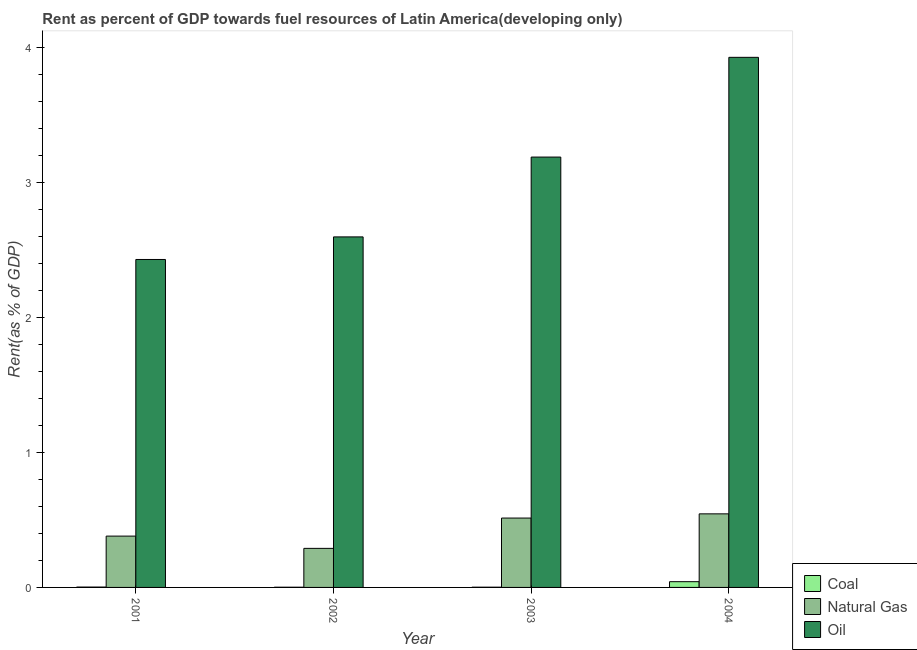How many different coloured bars are there?
Your answer should be very brief. 3. How many groups of bars are there?
Ensure brevity in your answer.  4. Are the number of bars per tick equal to the number of legend labels?
Offer a very short reply. Yes. What is the label of the 1st group of bars from the left?
Make the answer very short. 2001. In how many cases, is the number of bars for a given year not equal to the number of legend labels?
Your response must be concise. 0. What is the rent towards coal in 2004?
Give a very brief answer. 0.04. Across all years, what is the maximum rent towards coal?
Keep it short and to the point. 0.04. Across all years, what is the minimum rent towards coal?
Ensure brevity in your answer.  0. In which year was the rent towards coal minimum?
Provide a succinct answer. 2002. What is the total rent towards oil in the graph?
Offer a very short reply. 12.15. What is the difference between the rent towards natural gas in 2001 and that in 2002?
Your response must be concise. 0.09. What is the difference between the rent towards oil in 2003 and the rent towards coal in 2004?
Your answer should be compact. -0.74. What is the average rent towards coal per year?
Your response must be concise. 0.01. In the year 2003, what is the difference between the rent towards natural gas and rent towards coal?
Offer a terse response. 0. What is the ratio of the rent towards oil in 2001 to that in 2004?
Your response must be concise. 0.62. Is the rent towards natural gas in 2001 less than that in 2003?
Your response must be concise. Yes. What is the difference between the highest and the second highest rent towards natural gas?
Offer a very short reply. 0.03. What is the difference between the highest and the lowest rent towards natural gas?
Offer a very short reply. 0.26. In how many years, is the rent towards natural gas greater than the average rent towards natural gas taken over all years?
Your answer should be very brief. 2. What does the 1st bar from the left in 2003 represents?
Give a very brief answer. Coal. What does the 2nd bar from the right in 2002 represents?
Keep it short and to the point. Natural Gas. Is it the case that in every year, the sum of the rent towards coal and rent towards natural gas is greater than the rent towards oil?
Your answer should be very brief. No. How many years are there in the graph?
Your answer should be compact. 4. What is the difference between two consecutive major ticks on the Y-axis?
Keep it short and to the point. 1. How many legend labels are there?
Make the answer very short. 3. How are the legend labels stacked?
Make the answer very short. Vertical. What is the title of the graph?
Your answer should be very brief. Rent as percent of GDP towards fuel resources of Latin America(developing only). What is the label or title of the Y-axis?
Give a very brief answer. Rent(as % of GDP). What is the Rent(as % of GDP) in Coal in 2001?
Your response must be concise. 0. What is the Rent(as % of GDP) of Natural Gas in 2001?
Keep it short and to the point. 0.38. What is the Rent(as % of GDP) of Oil in 2001?
Provide a short and direct response. 2.43. What is the Rent(as % of GDP) in Coal in 2002?
Make the answer very short. 0. What is the Rent(as % of GDP) of Natural Gas in 2002?
Your answer should be compact. 0.29. What is the Rent(as % of GDP) of Oil in 2002?
Provide a succinct answer. 2.6. What is the Rent(as % of GDP) in Coal in 2003?
Ensure brevity in your answer.  0. What is the Rent(as % of GDP) in Natural Gas in 2003?
Make the answer very short. 0.51. What is the Rent(as % of GDP) of Oil in 2003?
Offer a very short reply. 3.19. What is the Rent(as % of GDP) in Coal in 2004?
Offer a terse response. 0.04. What is the Rent(as % of GDP) in Natural Gas in 2004?
Provide a short and direct response. 0.55. What is the Rent(as % of GDP) of Oil in 2004?
Your response must be concise. 3.93. Across all years, what is the maximum Rent(as % of GDP) of Coal?
Your answer should be very brief. 0.04. Across all years, what is the maximum Rent(as % of GDP) in Natural Gas?
Ensure brevity in your answer.  0.55. Across all years, what is the maximum Rent(as % of GDP) in Oil?
Give a very brief answer. 3.93. Across all years, what is the minimum Rent(as % of GDP) of Coal?
Keep it short and to the point. 0. Across all years, what is the minimum Rent(as % of GDP) in Natural Gas?
Make the answer very short. 0.29. Across all years, what is the minimum Rent(as % of GDP) of Oil?
Ensure brevity in your answer.  2.43. What is the total Rent(as % of GDP) of Coal in the graph?
Make the answer very short. 0.05. What is the total Rent(as % of GDP) in Natural Gas in the graph?
Offer a terse response. 1.73. What is the total Rent(as % of GDP) in Oil in the graph?
Provide a short and direct response. 12.15. What is the difference between the Rent(as % of GDP) in Coal in 2001 and that in 2002?
Offer a very short reply. 0. What is the difference between the Rent(as % of GDP) of Natural Gas in 2001 and that in 2002?
Provide a short and direct response. 0.09. What is the difference between the Rent(as % of GDP) in Oil in 2001 and that in 2002?
Offer a terse response. -0.17. What is the difference between the Rent(as % of GDP) in Coal in 2001 and that in 2003?
Offer a very short reply. 0. What is the difference between the Rent(as % of GDP) of Natural Gas in 2001 and that in 2003?
Your response must be concise. -0.13. What is the difference between the Rent(as % of GDP) of Oil in 2001 and that in 2003?
Provide a succinct answer. -0.76. What is the difference between the Rent(as % of GDP) in Coal in 2001 and that in 2004?
Give a very brief answer. -0.04. What is the difference between the Rent(as % of GDP) of Natural Gas in 2001 and that in 2004?
Your response must be concise. -0.16. What is the difference between the Rent(as % of GDP) of Oil in 2001 and that in 2004?
Your answer should be very brief. -1.5. What is the difference between the Rent(as % of GDP) in Coal in 2002 and that in 2003?
Your answer should be compact. -0. What is the difference between the Rent(as % of GDP) in Natural Gas in 2002 and that in 2003?
Offer a very short reply. -0.22. What is the difference between the Rent(as % of GDP) in Oil in 2002 and that in 2003?
Give a very brief answer. -0.59. What is the difference between the Rent(as % of GDP) of Coal in 2002 and that in 2004?
Provide a short and direct response. -0.04. What is the difference between the Rent(as % of GDP) of Natural Gas in 2002 and that in 2004?
Ensure brevity in your answer.  -0.26. What is the difference between the Rent(as % of GDP) in Oil in 2002 and that in 2004?
Give a very brief answer. -1.33. What is the difference between the Rent(as % of GDP) of Coal in 2003 and that in 2004?
Offer a very short reply. -0.04. What is the difference between the Rent(as % of GDP) in Natural Gas in 2003 and that in 2004?
Your answer should be compact. -0.03. What is the difference between the Rent(as % of GDP) of Oil in 2003 and that in 2004?
Your answer should be very brief. -0.74. What is the difference between the Rent(as % of GDP) of Coal in 2001 and the Rent(as % of GDP) of Natural Gas in 2002?
Provide a short and direct response. -0.29. What is the difference between the Rent(as % of GDP) of Coal in 2001 and the Rent(as % of GDP) of Oil in 2002?
Make the answer very short. -2.6. What is the difference between the Rent(as % of GDP) in Natural Gas in 2001 and the Rent(as % of GDP) in Oil in 2002?
Provide a succinct answer. -2.22. What is the difference between the Rent(as % of GDP) of Coal in 2001 and the Rent(as % of GDP) of Natural Gas in 2003?
Your answer should be very brief. -0.51. What is the difference between the Rent(as % of GDP) in Coal in 2001 and the Rent(as % of GDP) in Oil in 2003?
Offer a terse response. -3.19. What is the difference between the Rent(as % of GDP) of Natural Gas in 2001 and the Rent(as % of GDP) of Oil in 2003?
Your answer should be very brief. -2.81. What is the difference between the Rent(as % of GDP) in Coal in 2001 and the Rent(as % of GDP) in Natural Gas in 2004?
Offer a very short reply. -0.54. What is the difference between the Rent(as % of GDP) of Coal in 2001 and the Rent(as % of GDP) of Oil in 2004?
Give a very brief answer. -3.93. What is the difference between the Rent(as % of GDP) of Natural Gas in 2001 and the Rent(as % of GDP) of Oil in 2004?
Your answer should be compact. -3.55. What is the difference between the Rent(as % of GDP) in Coal in 2002 and the Rent(as % of GDP) in Natural Gas in 2003?
Give a very brief answer. -0.51. What is the difference between the Rent(as % of GDP) of Coal in 2002 and the Rent(as % of GDP) of Oil in 2003?
Keep it short and to the point. -3.19. What is the difference between the Rent(as % of GDP) in Natural Gas in 2002 and the Rent(as % of GDP) in Oil in 2003?
Provide a succinct answer. -2.9. What is the difference between the Rent(as % of GDP) of Coal in 2002 and the Rent(as % of GDP) of Natural Gas in 2004?
Provide a succinct answer. -0.54. What is the difference between the Rent(as % of GDP) in Coal in 2002 and the Rent(as % of GDP) in Oil in 2004?
Your answer should be very brief. -3.93. What is the difference between the Rent(as % of GDP) of Natural Gas in 2002 and the Rent(as % of GDP) of Oil in 2004?
Give a very brief answer. -3.64. What is the difference between the Rent(as % of GDP) of Coal in 2003 and the Rent(as % of GDP) of Natural Gas in 2004?
Make the answer very short. -0.54. What is the difference between the Rent(as % of GDP) in Coal in 2003 and the Rent(as % of GDP) in Oil in 2004?
Offer a terse response. -3.93. What is the difference between the Rent(as % of GDP) in Natural Gas in 2003 and the Rent(as % of GDP) in Oil in 2004?
Make the answer very short. -3.41. What is the average Rent(as % of GDP) in Coal per year?
Your response must be concise. 0.01. What is the average Rent(as % of GDP) of Natural Gas per year?
Make the answer very short. 0.43. What is the average Rent(as % of GDP) in Oil per year?
Offer a very short reply. 3.04. In the year 2001, what is the difference between the Rent(as % of GDP) in Coal and Rent(as % of GDP) in Natural Gas?
Provide a short and direct response. -0.38. In the year 2001, what is the difference between the Rent(as % of GDP) in Coal and Rent(as % of GDP) in Oil?
Your answer should be very brief. -2.43. In the year 2001, what is the difference between the Rent(as % of GDP) of Natural Gas and Rent(as % of GDP) of Oil?
Your answer should be compact. -2.05. In the year 2002, what is the difference between the Rent(as % of GDP) in Coal and Rent(as % of GDP) in Natural Gas?
Make the answer very short. -0.29. In the year 2002, what is the difference between the Rent(as % of GDP) in Coal and Rent(as % of GDP) in Oil?
Make the answer very short. -2.6. In the year 2002, what is the difference between the Rent(as % of GDP) of Natural Gas and Rent(as % of GDP) of Oil?
Your answer should be compact. -2.31. In the year 2003, what is the difference between the Rent(as % of GDP) in Coal and Rent(as % of GDP) in Natural Gas?
Make the answer very short. -0.51. In the year 2003, what is the difference between the Rent(as % of GDP) of Coal and Rent(as % of GDP) of Oil?
Your answer should be very brief. -3.19. In the year 2003, what is the difference between the Rent(as % of GDP) in Natural Gas and Rent(as % of GDP) in Oil?
Offer a terse response. -2.68. In the year 2004, what is the difference between the Rent(as % of GDP) in Coal and Rent(as % of GDP) in Natural Gas?
Provide a short and direct response. -0.5. In the year 2004, what is the difference between the Rent(as % of GDP) of Coal and Rent(as % of GDP) of Oil?
Your response must be concise. -3.89. In the year 2004, what is the difference between the Rent(as % of GDP) of Natural Gas and Rent(as % of GDP) of Oil?
Your answer should be compact. -3.38. What is the ratio of the Rent(as % of GDP) in Coal in 2001 to that in 2002?
Make the answer very short. 1.8. What is the ratio of the Rent(as % of GDP) of Natural Gas in 2001 to that in 2002?
Your answer should be compact. 1.31. What is the ratio of the Rent(as % of GDP) of Oil in 2001 to that in 2002?
Make the answer very short. 0.94. What is the ratio of the Rent(as % of GDP) of Coal in 2001 to that in 2003?
Offer a terse response. 1.48. What is the ratio of the Rent(as % of GDP) in Natural Gas in 2001 to that in 2003?
Your answer should be very brief. 0.74. What is the ratio of the Rent(as % of GDP) in Oil in 2001 to that in 2003?
Make the answer very short. 0.76. What is the ratio of the Rent(as % of GDP) of Coal in 2001 to that in 2004?
Give a very brief answer. 0.06. What is the ratio of the Rent(as % of GDP) in Natural Gas in 2001 to that in 2004?
Provide a short and direct response. 0.7. What is the ratio of the Rent(as % of GDP) of Oil in 2001 to that in 2004?
Ensure brevity in your answer.  0.62. What is the ratio of the Rent(as % of GDP) of Coal in 2002 to that in 2003?
Keep it short and to the point. 0.82. What is the ratio of the Rent(as % of GDP) of Natural Gas in 2002 to that in 2003?
Keep it short and to the point. 0.56. What is the ratio of the Rent(as % of GDP) of Oil in 2002 to that in 2003?
Your answer should be compact. 0.81. What is the ratio of the Rent(as % of GDP) in Coal in 2002 to that in 2004?
Ensure brevity in your answer.  0.03. What is the ratio of the Rent(as % of GDP) in Natural Gas in 2002 to that in 2004?
Offer a very short reply. 0.53. What is the ratio of the Rent(as % of GDP) of Oil in 2002 to that in 2004?
Make the answer very short. 0.66. What is the ratio of the Rent(as % of GDP) in Coal in 2003 to that in 2004?
Make the answer very short. 0.04. What is the ratio of the Rent(as % of GDP) in Natural Gas in 2003 to that in 2004?
Give a very brief answer. 0.94. What is the ratio of the Rent(as % of GDP) of Oil in 2003 to that in 2004?
Give a very brief answer. 0.81. What is the difference between the highest and the second highest Rent(as % of GDP) in Coal?
Offer a very short reply. 0.04. What is the difference between the highest and the second highest Rent(as % of GDP) of Natural Gas?
Your answer should be compact. 0.03. What is the difference between the highest and the second highest Rent(as % of GDP) in Oil?
Provide a succinct answer. 0.74. What is the difference between the highest and the lowest Rent(as % of GDP) in Coal?
Provide a succinct answer. 0.04. What is the difference between the highest and the lowest Rent(as % of GDP) of Natural Gas?
Provide a short and direct response. 0.26. What is the difference between the highest and the lowest Rent(as % of GDP) of Oil?
Keep it short and to the point. 1.5. 